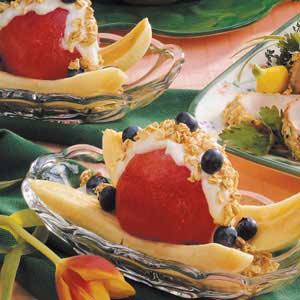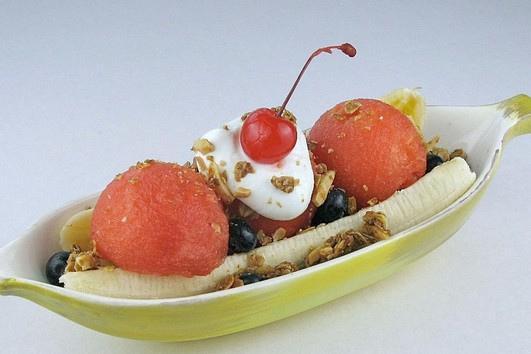The first image is the image on the left, the second image is the image on the right. For the images displayed, is the sentence "There are round banana slices." factually correct? Answer yes or no. No. The first image is the image on the left, the second image is the image on the right. For the images displayed, is the sentence "The left image includes an oblong clear glass bowl containing a split banana with blueberries and other toppings on it." factually correct? Answer yes or no. Yes. 